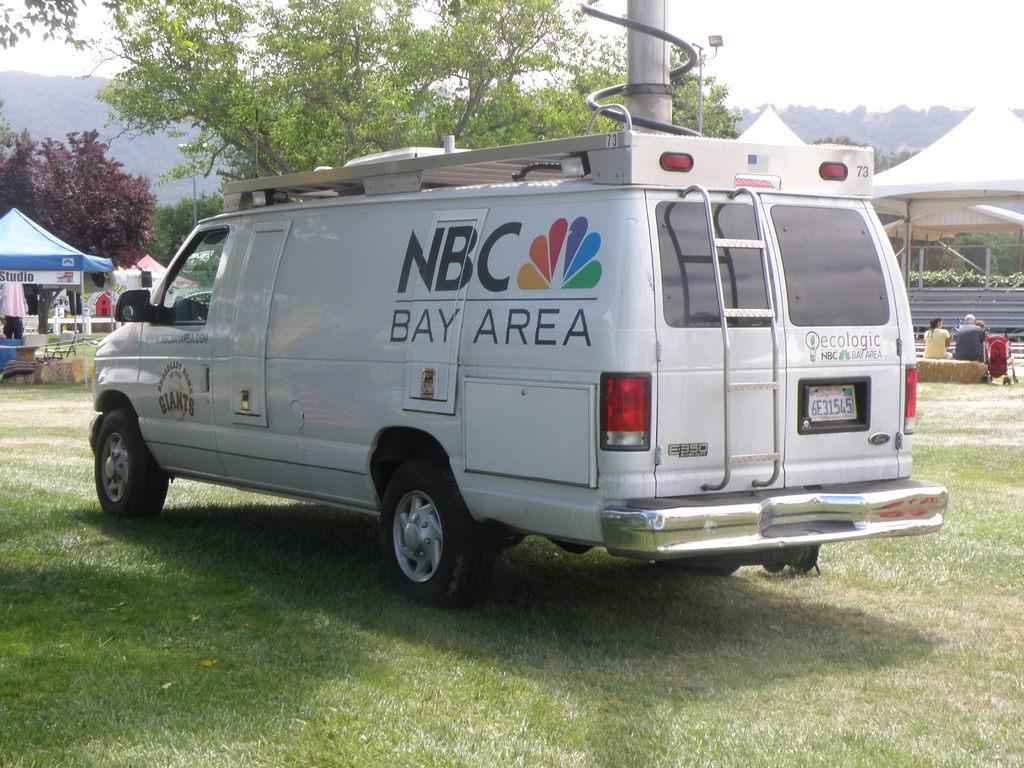What type of vehicle is on the grass in the image? There is a van on the grass in the image. What can be seen in the background of the image? There are people, tents, and trees in the background of the image. What type of rings can be seen on the van in the image? There are no rings visible on the van in the image. Is there a church in the background of the image? There is no church present in the image; only people, tents, and trees can be seen in the background. 